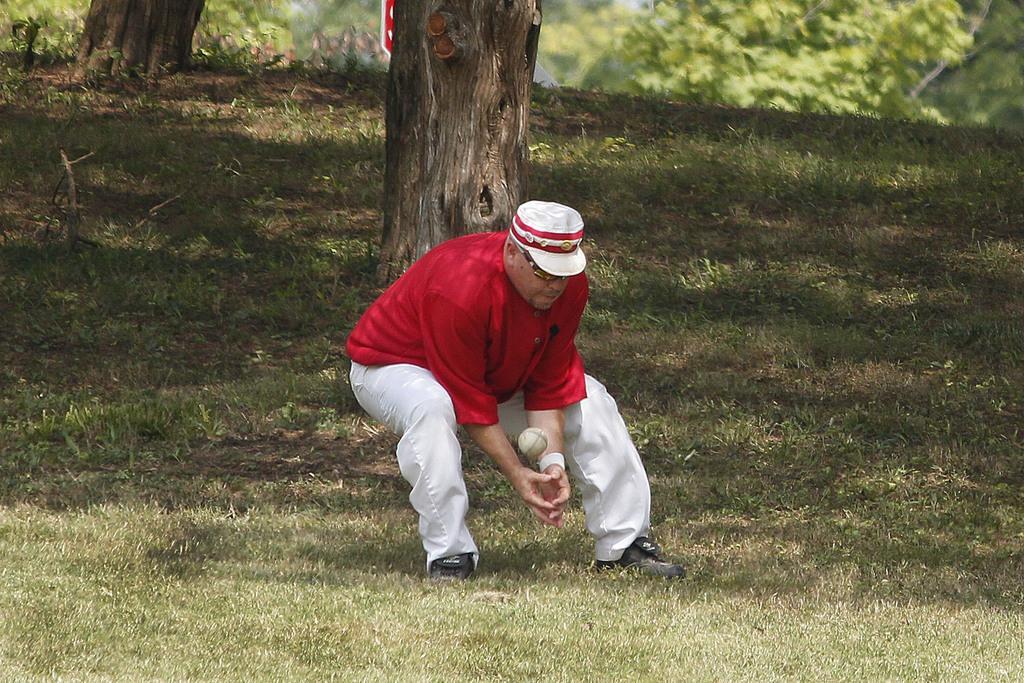In one or two sentences, can you explain what this image depicts? As we can see in the image there is grass, tree stem, trees, ball and there is a person wearing red color t shirt and hat. 